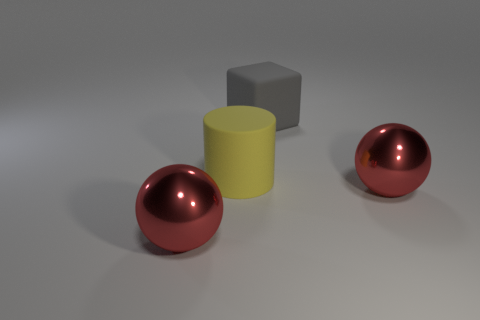Add 2 balls. How many objects exist? 6 Subtract all cylinders. How many objects are left? 3 Add 4 large gray things. How many large gray things exist? 5 Subtract 0 green cylinders. How many objects are left? 4 Subtract all green things. Subtract all gray matte things. How many objects are left? 3 Add 4 yellow cylinders. How many yellow cylinders are left? 5 